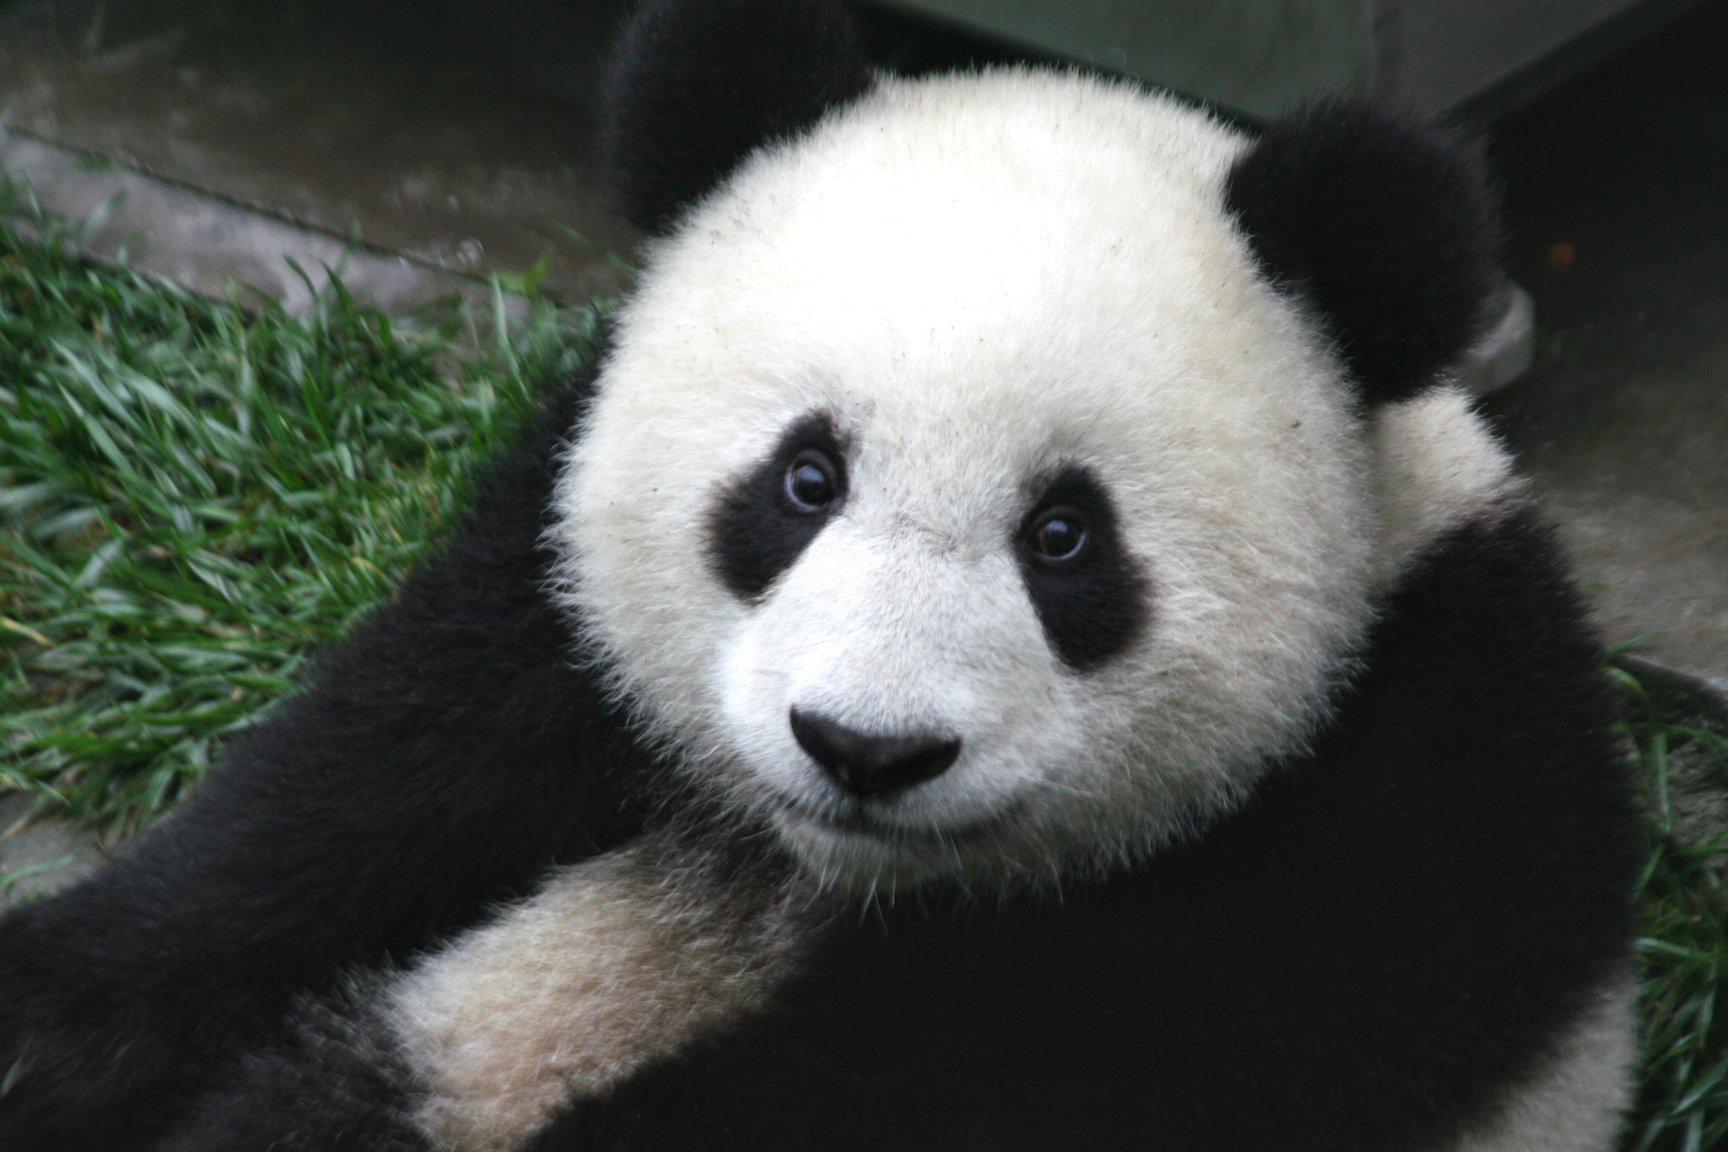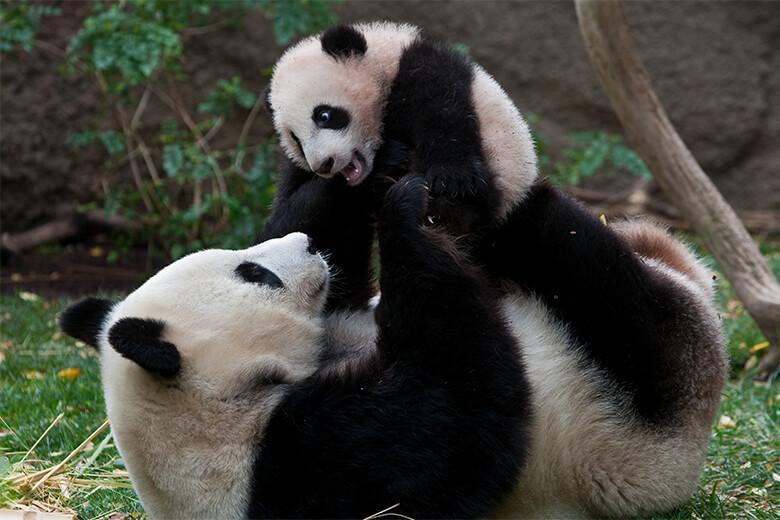The first image is the image on the left, the second image is the image on the right. Examine the images to the left and right. Is the description "There are three panda bears" accurate? Answer yes or no. Yes. The first image is the image on the left, the second image is the image on the right. Given the left and right images, does the statement "An image shows an adult panda on its back, playing with a young panda on top." hold true? Answer yes or no. Yes. 